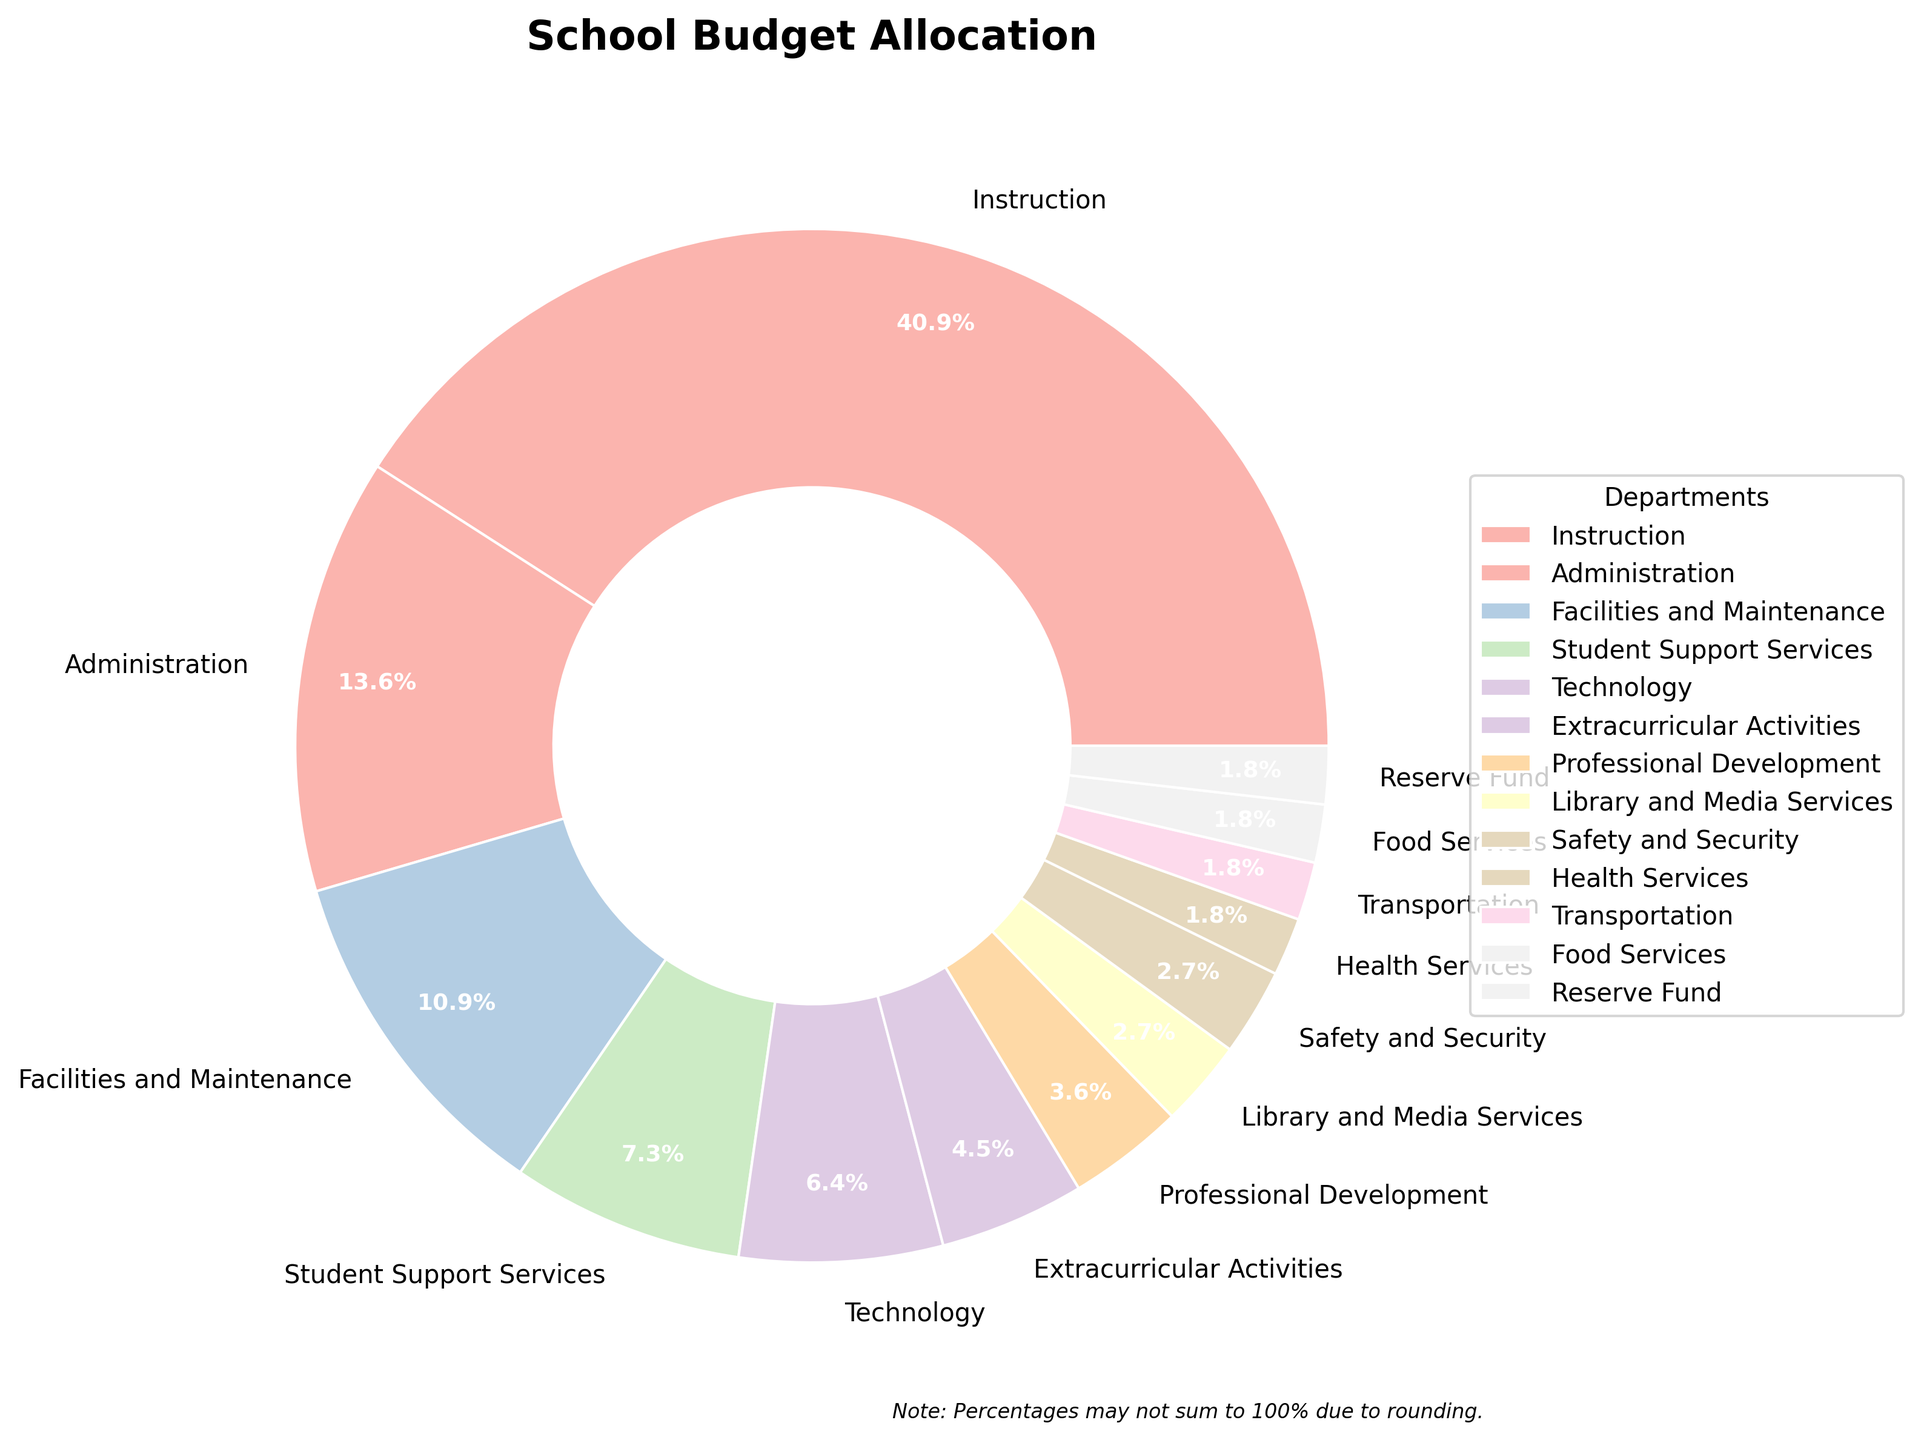What is the percentage allocation for Instruction? The figure displays the percentage allocations for each department. Locate the "Instruction" segment, which is clearly labeled with its percentage.
Answer: 45% Which department has the smallest budget allocation? Look at the pie chart and identify the department with the smallest slice. According to the chart, it is the department labeled "Health Services," "Transportation," "Food Services," or "Reserve Fund," each with 2%.
Answer: Health Services, Transportation, Food Services, and Reserve Fund What is the combined budget allocation percentage for Health Services, Transportation, and Food Services? These departments each have a budget allocation of 2%. Adding these percentages together: 2% (Health Services) + 2% (Transportation) + 2% (Food Services) = 6%.
Answer: 6% Is the allocation for Professional Development greater than that for Extracurricular Activities? Compare the slices labeled "Professional Development" and "Extracurricular Activities". Professional Development is 4% while Extracurricular Activities is 5%.
Answer: No How much more percentage is allocated to Technology than to Library and Media Services? Find the percentages for Technology and Library and Media Services from the labeled slices. Technology is allocated 7% and Library and Media Services 3%. Subtract the smaller allocation from the larger: 7% - 3% = 4%.
Answer: 4% Which three departments have the highest budget allocations? Identify the three largest slices in the pie chart. They belong to the departments labeled "Instruction" (45%), "Administration" (15%), and "Facilities and Maintenance" (12%).
Answer: Instruction, Administration, Facilities and Maintenance By how much does the percentage of Student Support Services exceed that of Safety and Security? The allocation for Student Support Services is 8%, while Safety and Security is allocated 3%. Calculate the difference: 8% - 3% = 5%.
Answer: 5% What is the percentage of the budget allocated to departments other than Instruction and Administration? First, sum the allocations for Instruction (45%) and Administration (15%): 45% + 15% = 60%. Subtract this from 100% to find the remaining allocation: 100% - 60% = 40%.
Answer: 40% Are there any departments with equal budget allocations? Examine the pie chart to find departments with the same percentage. Health Services, Transportation, Food Services, and Reserve Fund all have 2% allocations.
Answer: Yes What is the total percentage allocation for departments related to student services (Student Support Services, Health Services, Transportation)? Add the percentages for these departments: 8% (Student Support Services) + 2% (Health Services) + 2% (Transportation) = 12%.
Answer: 12% 